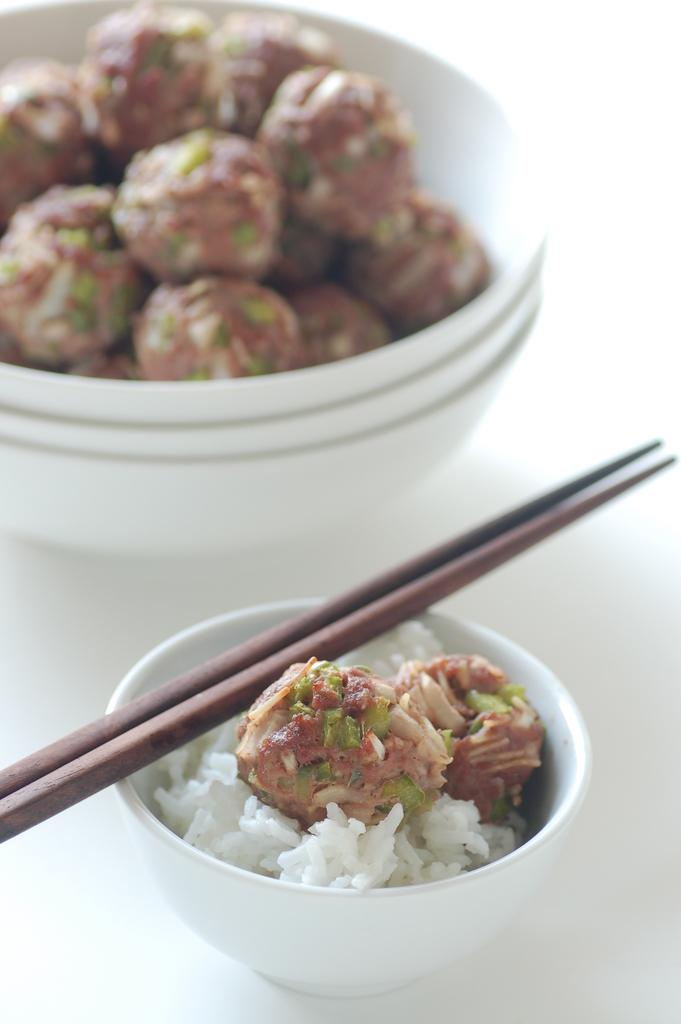What is in the bowl that is visible in the image? There is a bowl in the image, and it contains rice and a laddu. What else is present in the bowl besides the rice and laddu? There is a stick in the bowl. How does the deer in the image draw attention to itself? There is no deer present in the image; it only features a bowl with rice, a laddu, and a stick. 